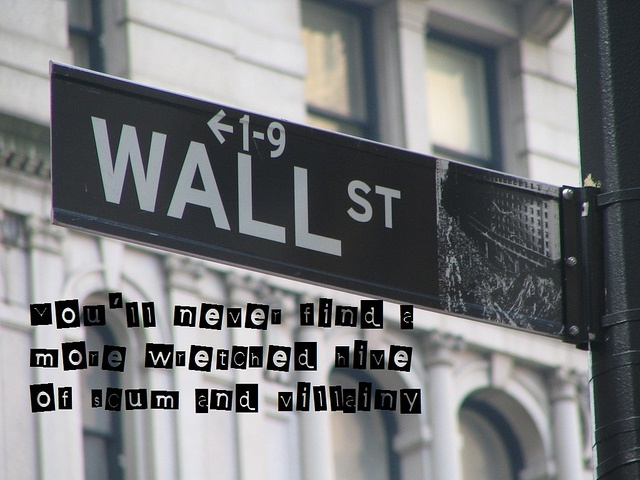Describe the objects in this image and their specific colors. I can see various objects in this image with different colors. 